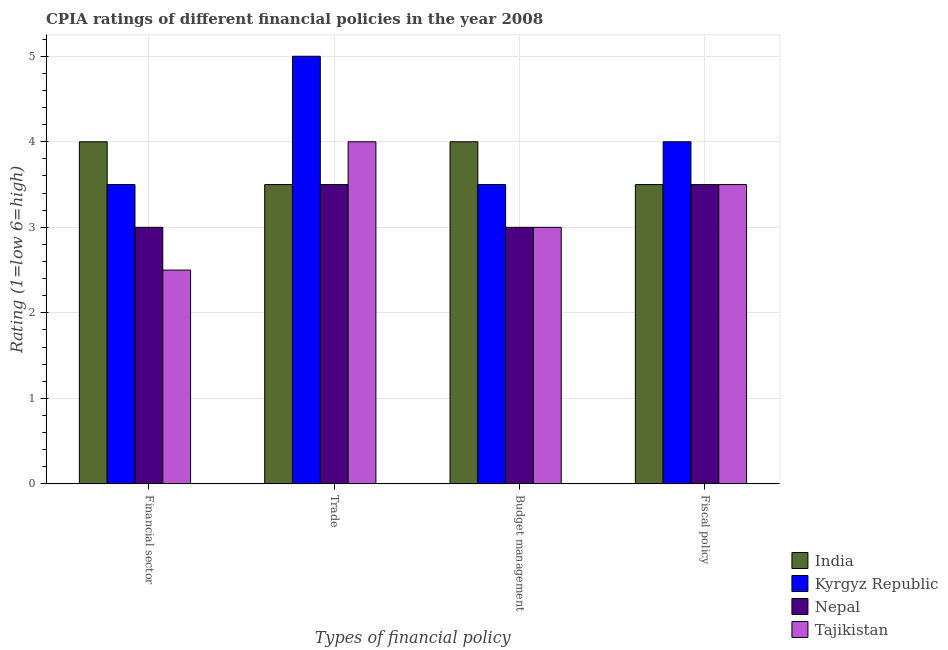How many groups of bars are there?
Provide a short and direct response. 4. Are the number of bars per tick equal to the number of legend labels?
Offer a terse response. Yes. How many bars are there on the 4th tick from the left?
Your answer should be compact. 4. What is the label of the 3rd group of bars from the left?
Provide a succinct answer. Budget management. Across all countries, what is the minimum cpia rating of budget management?
Make the answer very short. 3. In which country was the cpia rating of financial sector minimum?
Give a very brief answer. Tajikistan. What is the difference between the cpia rating of financial sector in Tajikistan and that in India?
Provide a succinct answer. -1.5. What is the average cpia rating of trade per country?
Offer a very short reply. 4. In how many countries, is the cpia rating of fiscal policy greater than 4.6 ?
Give a very brief answer. 0. Is the cpia rating of budget management in Kyrgyz Republic less than that in Nepal?
Offer a very short reply. No. Is the difference between the cpia rating of trade in Kyrgyz Republic and Nepal greater than the difference between the cpia rating of budget management in Kyrgyz Republic and Nepal?
Give a very brief answer. Yes. Is the sum of the cpia rating of fiscal policy in Tajikistan and Kyrgyz Republic greater than the maximum cpia rating of financial sector across all countries?
Your answer should be very brief. Yes. Is it the case that in every country, the sum of the cpia rating of financial sector and cpia rating of budget management is greater than the sum of cpia rating of fiscal policy and cpia rating of trade?
Your response must be concise. No. What does the 1st bar from the left in Financial sector represents?
Make the answer very short. India. What does the 3rd bar from the right in Financial sector represents?
Provide a succinct answer. Kyrgyz Republic. Does the graph contain grids?
Your answer should be very brief. Yes. Where does the legend appear in the graph?
Offer a very short reply. Bottom right. How many legend labels are there?
Offer a very short reply. 4. What is the title of the graph?
Provide a succinct answer. CPIA ratings of different financial policies in the year 2008. Does "Iceland" appear as one of the legend labels in the graph?
Offer a terse response. No. What is the label or title of the X-axis?
Your answer should be very brief. Types of financial policy. What is the Rating (1=low 6=high) of Tajikistan in Financial sector?
Your answer should be very brief. 2.5. What is the Rating (1=low 6=high) in Tajikistan in Trade?
Provide a succinct answer. 4. What is the Rating (1=low 6=high) in India in Fiscal policy?
Give a very brief answer. 3.5. Across all Types of financial policy, what is the maximum Rating (1=low 6=high) of India?
Ensure brevity in your answer.  4. Across all Types of financial policy, what is the maximum Rating (1=low 6=high) in Nepal?
Ensure brevity in your answer.  3.5. Across all Types of financial policy, what is the minimum Rating (1=low 6=high) in India?
Provide a short and direct response. 3.5. What is the difference between the Rating (1=low 6=high) in India in Financial sector and that in Trade?
Your answer should be compact. 0.5. What is the difference between the Rating (1=low 6=high) of Kyrgyz Republic in Financial sector and that in Trade?
Your answer should be compact. -1.5. What is the difference between the Rating (1=low 6=high) in Tajikistan in Financial sector and that in Trade?
Your answer should be very brief. -1.5. What is the difference between the Rating (1=low 6=high) in India in Financial sector and that in Budget management?
Make the answer very short. 0. What is the difference between the Rating (1=low 6=high) of Kyrgyz Republic in Financial sector and that in Budget management?
Your answer should be compact. 0. What is the difference between the Rating (1=low 6=high) in Nepal in Financial sector and that in Budget management?
Your answer should be compact. 0. What is the difference between the Rating (1=low 6=high) of India in Financial sector and that in Fiscal policy?
Offer a terse response. 0.5. What is the difference between the Rating (1=low 6=high) of Kyrgyz Republic in Financial sector and that in Fiscal policy?
Ensure brevity in your answer.  -0.5. What is the difference between the Rating (1=low 6=high) in Nepal in Financial sector and that in Fiscal policy?
Keep it short and to the point. -0.5. What is the difference between the Rating (1=low 6=high) of Tajikistan in Financial sector and that in Fiscal policy?
Ensure brevity in your answer.  -1. What is the difference between the Rating (1=low 6=high) in India in Trade and that in Budget management?
Provide a succinct answer. -0.5. What is the difference between the Rating (1=low 6=high) in Kyrgyz Republic in Trade and that in Budget management?
Your answer should be compact. 1.5. What is the difference between the Rating (1=low 6=high) of Tajikistan in Trade and that in Budget management?
Make the answer very short. 1. What is the difference between the Rating (1=low 6=high) in Kyrgyz Republic in Trade and that in Fiscal policy?
Offer a very short reply. 1. What is the difference between the Rating (1=low 6=high) of India in Budget management and that in Fiscal policy?
Keep it short and to the point. 0.5. What is the difference between the Rating (1=low 6=high) in Kyrgyz Republic in Budget management and that in Fiscal policy?
Keep it short and to the point. -0.5. What is the difference between the Rating (1=low 6=high) in India in Financial sector and the Rating (1=low 6=high) in Kyrgyz Republic in Trade?
Your response must be concise. -1. What is the difference between the Rating (1=low 6=high) of India in Financial sector and the Rating (1=low 6=high) of Nepal in Trade?
Offer a very short reply. 0.5. What is the difference between the Rating (1=low 6=high) of India in Financial sector and the Rating (1=low 6=high) of Tajikistan in Trade?
Offer a terse response. 0. What is the difference between the Rating (1=low 6=high) of Kyrgyz Republic in Financial sector and the Rating (1=low 6=high) of Tajikistan in Trade?
Provide a short and direct response. -0.5. What is the difference between the Rating (1=low 6=high) of Nepal in Financial sector and the Rating (1=low 6=high) of Tajikistan in Trade?
Make the answer very short. -1. What is the difference between the Rating (1=low 6=high) in India in Financial sector and the Rating (1=low 6=high) in Nepal in Budget management?
Offer a very short reply. 1. What is the difference between the Rating (1=low 6=high) of India in Financial sector and the Rating (1=low 6=high) of Tajikistan in Budget management?
Offer a very short reply. 1. What is the difference between the Rating (1=low 6=high) in Kyrgyz Republic in Financial sector and the Rating (1=low 6=high) in Nepal in Budget management?
Provide a short and direct response. 0.5. What is the difference between the Rating (1=low 6=high) in Nepal in Financial sector and the Rating (1=low 6=high) in Tajikistan in Budget management?
Your answer should be compact. 0. What is the difference between the Rating (1=low 6=high) of Kyrgyz Republic in Financial sector and the Rating (1=low 6=high) of Nepal in Fiscal policy?
Offer a very short reply. 0. What is the difference between the Rating (1=low 6=high) in Kyrgyz Republic in Financial sector and the Rating (1=low 6=high) in Tajikistan in Fiscal policy?
Keep it short and to the point. 0. What is the difference between the Rating (1=low 6=high) in India in Trade and the Rating (1=low 6=high) in Nepal in Budget management?
Your answer should be very brief. 0.5. What is the difference between the Rating (1=low 6=high) of India in Trade and the Rating (1=low 6=high) of Tajikistan in Budget management?
Offer a terse response. 0.5. What is the difference between the Rating (1=low 6=high) of Nepal in Trade and the Rating (1=low 6=high) of Tajikistan in Budget management?
Offer a very short reply. 0.5. What is the difference between the Rating (1=low 6=high) in Nepal in Trade and the Rating (1=low 6=high) in Tajikistan in Fiscal policy?
Offer a terse response. 0. What is the difference between the Rating (1=low 6=high) in India in Budget management and the Rating (1=low 6=high) in Kyrgyz Republic in Fiscal policy?
Provide a succinct answer. 0. What is the difference between the Rating (1=low 6=high) of India in Budget management and the Rating (1=low 6=high) of Nepal in Fiscal policy?
Keep it short and to the point. 0.5. What is the difference between the Rating (1=low 6=high) in Kyrgyz Republic in Budget management and the Rating (1=low 6=high) in Nepal in Fiscal policy?
Provide a short and direct response. 0. What is the average Rating (1=low 6=high) in India per Types of financial policy?
Your answer should be very brief. 3.75. What is the average Rating (1=low 6=high) in Nepal per Types of financial policy?
Your answer should be very brief. 3.25. What is the average Rating (1=low 6=high) of Tajikistan per Types of financial policy?
Your answer should be very brief. 3.25. What is the difference between the Rating (1=low 6=high) in India and Rating (1=low 6=high) in Tajikistan in Financial sector?
Your answer should be compact. 1.5. What is the difference between the Rating (1=low 6=high) in Kyrgyz Republic and Rating (1=low 6=high) in Nepal in Financial sector?
Ensure brevity in your answer.  0.5. What is the difference between the Rating (1=low 6=high) of India and Rating (1=low 6=high) of Nepal in Trade?
Offer a very short reply. 0. What is the difference between the Rating (1=low 6=high) of India and Rating (1=low 6=high) of Tajikistan in Trade?
Keep it short and to the point. -0.5. What is the difference between the Rating (1=low 6=high) of Kyrgyz Republic and Rating (1=low 6=high) of Nepal in Trade?
Your answer should be compact. 1.5. What is the difference between the Rating (1=low 6=high) of Kyrgyz Republic and Rating (1=low 6=high) of Tajikistan in Trade?
Provide a short and direct response. 1. What is the difference between the Rating (1=low 6=high) in Nepal and Rating (1=low 6=high) in Tajikistan in Trade?
Provide a succinct answer. -0.5. What is the difference between the Rating (1=low 6=high) of India and Rating (1=low 6=high) of Kyrgyz Republic in Budget management?
Offer a terse response. 0.5. What is the difference between the Rating (1=low 6=high) in Kyrgyz Republic and Rating (1=low 6=high) in Tajikistan in Budget management?
Make the answer very short. 0.5. What is the difference between the Rating (1=low 6=high) of India and Rating (1=low 6=high) of Kyrgyz Republic in Fiscal policy?
Make the answer very short. -0.5. What is the difference between the Rating (1=low 6=high) in India and Rating (1=low 6=high) in Nepal in Fiscal policy?
Make the answer very short. 0. What is the difference between the Rating (1=low 6=high) of Kyrgyz Republic and Rating (1=low 6=high) of Nepal in Fiscal policy?
Keep it short and to the point. 0.5. What is the difference between the Rating (1=low 6=high) of Kyrgyz Republic and Rating (1=low 6=high) of Tajikistan in Fiscal policy?
Ensure brevity in your answer.  0.5. What is the difference between the Rating (1=low 6=high) of Nepal and Rating (1=low 6=high) of Tajikistan in Fiscal policy?
Make the answer very short. 0. What is the ratio of the Rating (1=low 6=high) in India in Financial sector to that in Trade?
Your answer should be compact. 1.14. What is the ratio of the Rating (1=low 6=high) of Nepal in Financial sector to that in Trade?
Keep it short and to the point. 0.86. What is the ratio of the Rating (1=low 6=high) of Tajikistan in Financial sector to that in Trade?
Offer a very short reply. 0.62. What is the ratio of the Rating (1=low 6=high) in India in Financial sector to that in Budget management?
Ensure brevity in your answer.  1. What is the ratio of the Rating (1=low 6=high) in Nepal in Financial sector to that in Budget management?
Offer a very short reply. 1. What is the ratio of the Rating (1=low 6=high) in India in Financial sector to that in Fiscal policy?
Your response must be concise. 1.14. What is the ratio of the Rating (1=low 6=high) in Nepal in Financial sector to that in Fiscal policy?
Offer a very short reply. 0.86. What is the ratio of the Rating (1=low 6=high) in India in Trade to that in Budget management?
Give a very brief answer. 0.88. What is the ratio of the Rating (1=low 6=high) of Kyrgyz Republic in Trade to that in Budget management?
Keep it short and to the point. 1.43. What is the ratio of the Rating (1=low 6=high) of Kyrgyz Republic in Trade to that in Fiscal policy?
Your response must be concise. 1.25. What is the ratio of the Rating (1=low 6=high) in Nepal in Trade to that in Fiscal policy?
Make the answer very short. 1. What is the ratio of the Rating (1=low 6=high) of Tajikistan in Trade to that in Fiscal policy?
Offer a terse response. 1.14. What is the ratio of the Rating (1=low 6=high) in Tajikistan in Budget management to that in Fiscal policy?
Offer a terse response. 0.86. What is the difference between the highest and the second highest Rating (1=low 6=high) in Kyrgyz Republic?
Provide a short and direct response. 1. What is the difference between the highest and the second highest Rating (1=low 6=high) in Tajikistan?
Provide a succinct answer. 0.5. What is the difference between the highest and the lowest Rating (1=low 6=high) of India?
Offer a terse response. 0.5. What is the difference between the highest and the lowest Rating (1=low 6=high) in Kyrgyz Republic?
Give a very brief answer. 1.5. 